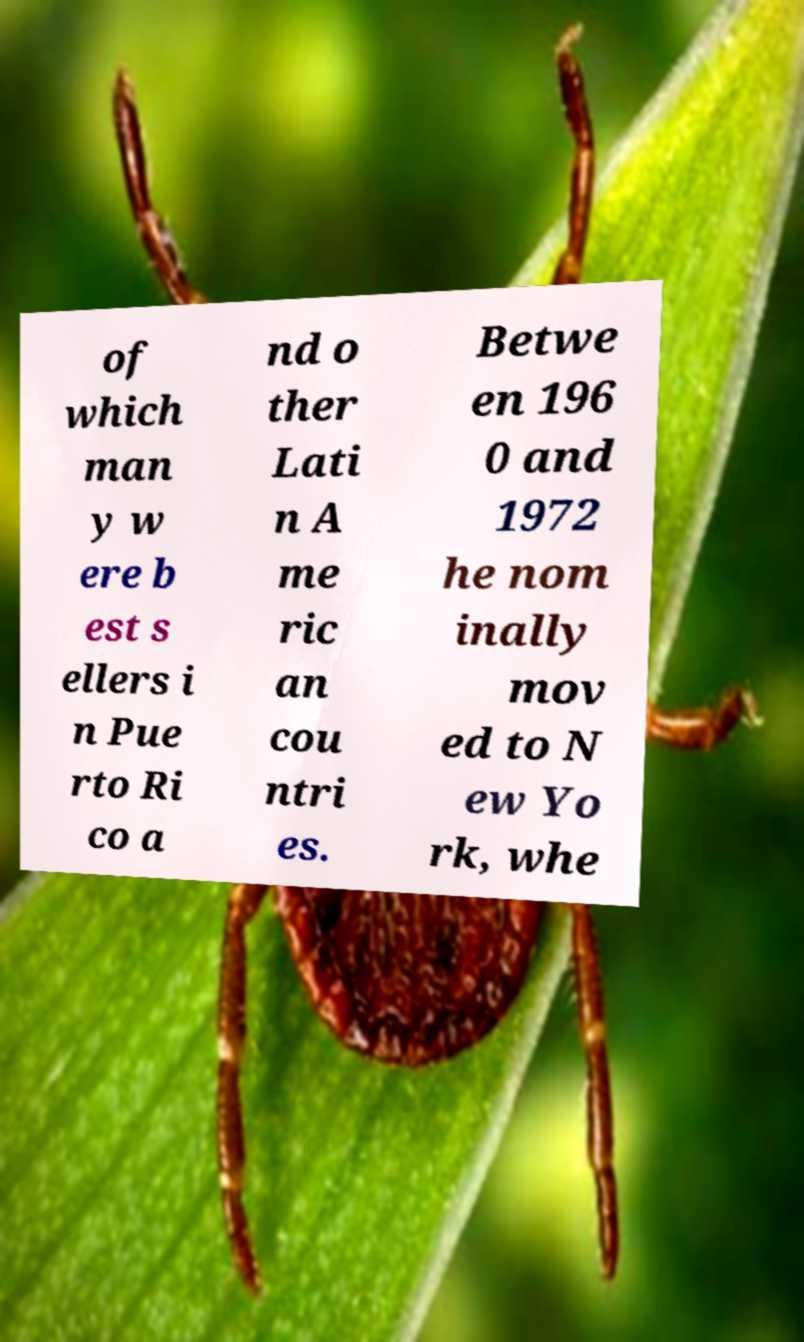Could you assist in decoding the text presented in this image and type it out clearly? of which man y w ere b est s ellers i n Pue rto Ri co a nd o ther Lati n A me ric an cou ntri es. Betwe en 196 0 and 1972 he nom inally mov ed to N ew Yo rk, whe 